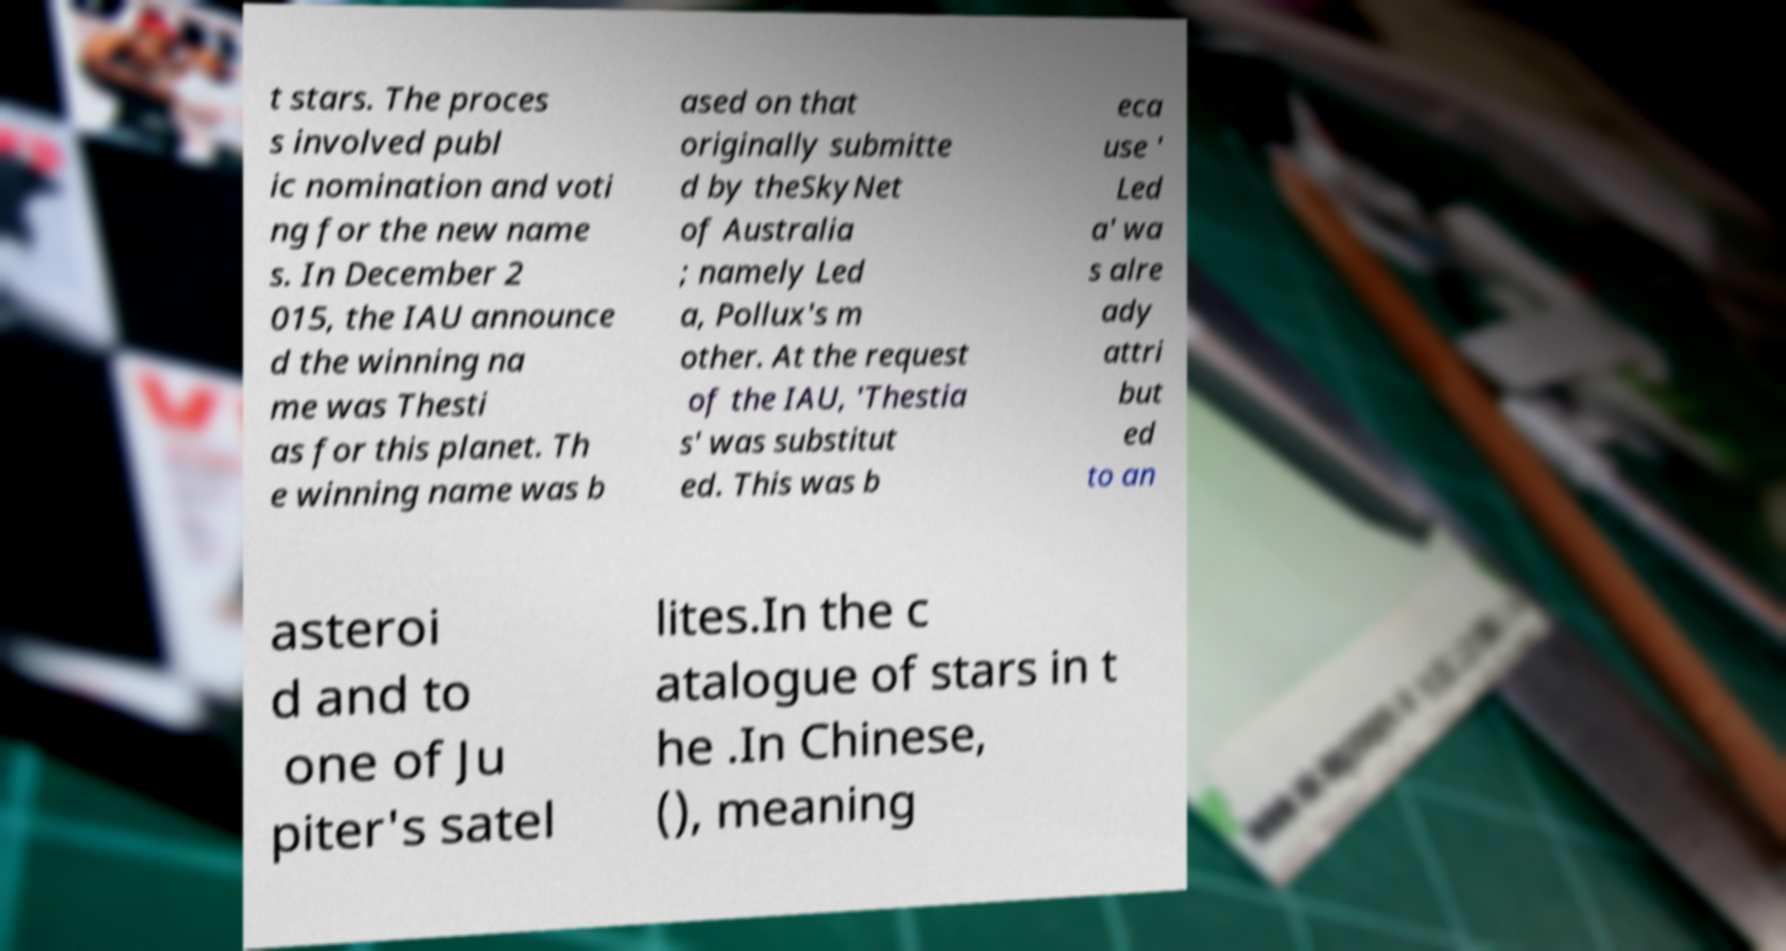Can you accurately transcribe the text from the provided image for me? t stars. The proces s involved publ ic nomination and voti ng for the new name s. In December 2 015, the IAU announce d the winning na me was Thesti as for this planet. Th e winning name was b ased on that originally submitte d by theSkyNet of Australia ; namely Led a, Pollux's m other. At the request of the IAU, 'Thestia s' was substitut ed. This was b eca use ' Led a' wa s alre ady attri but ed to an asteroi d and to one of Ju piter's satel lites.In the c atalogue of stars in t he .In Chinese, (), meaning 